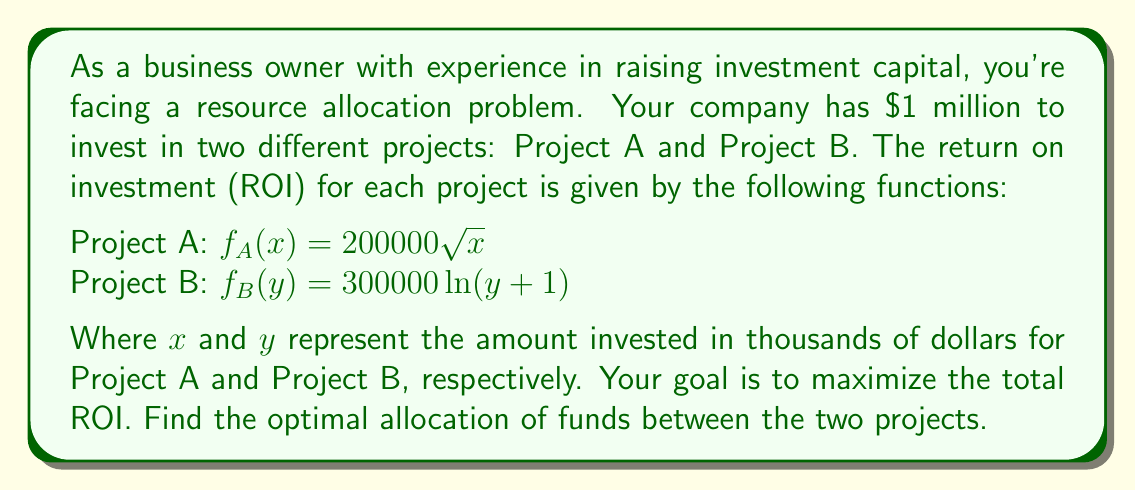Can you answer this question? To solve this optimization problem, we'll use the method of Lagrange multipliers:

1) Let's define our objective function:
   $F(x,y) = f_A(x) + f_B(y) = 200000\sqrt{x} + 300000\ln(y+1)$

2) Our constraint is:
   $g(x,y) = x + y - 1000 = 0$ (since we have $1 million to invest)

3) Form the Lagrangian:
   $L(x,y,\lambda) = F(x,y) - \lambda g(x,y)$
   $L(x,y,\lambda) = 200000\sqrt{x} + 300000\ln(y+1) - \lambda(x + y - 1000)$

4) Take partial derivatives and set them to zero:
   $\frac{\partial L}{\partial x} = \frac{100000}{\sqrt{x}} - \lambda = 0$
   $\frac{\partial L}{\partial y} = \frac{300000}{y+1} - \lambda = 0$
   $\frac{\partial L}{\partial \lambda} = x + y - 1000 = 0$

5) From the first two equations:
   $\frac{100000}{\sqrt{x}} = \frac{300000}{y+1}$

6) Simplify:
   $3(y+1) = \sqrt{x}$
   $y = \frac{\sqrt{x}}{3} - 1$

7) Substitute into the constraint equation:
   $x + (\frac{\sqrt{x}}{3} - 1) = 1000$
   $x + \frac{\sqrt{x}}{3} = 1001$

8) Solve this equation numerically (e.g., using Newton's method):
   $x \approx 563.47$

9) Therefore:
   $y \approx 1000 - 563.47 = 436.53$

10) Round to the nearest thousand dollars:
    $x = 563,000$ and $y = 437,000$
Answer: Project A: $563,000, Project B: $437,000 